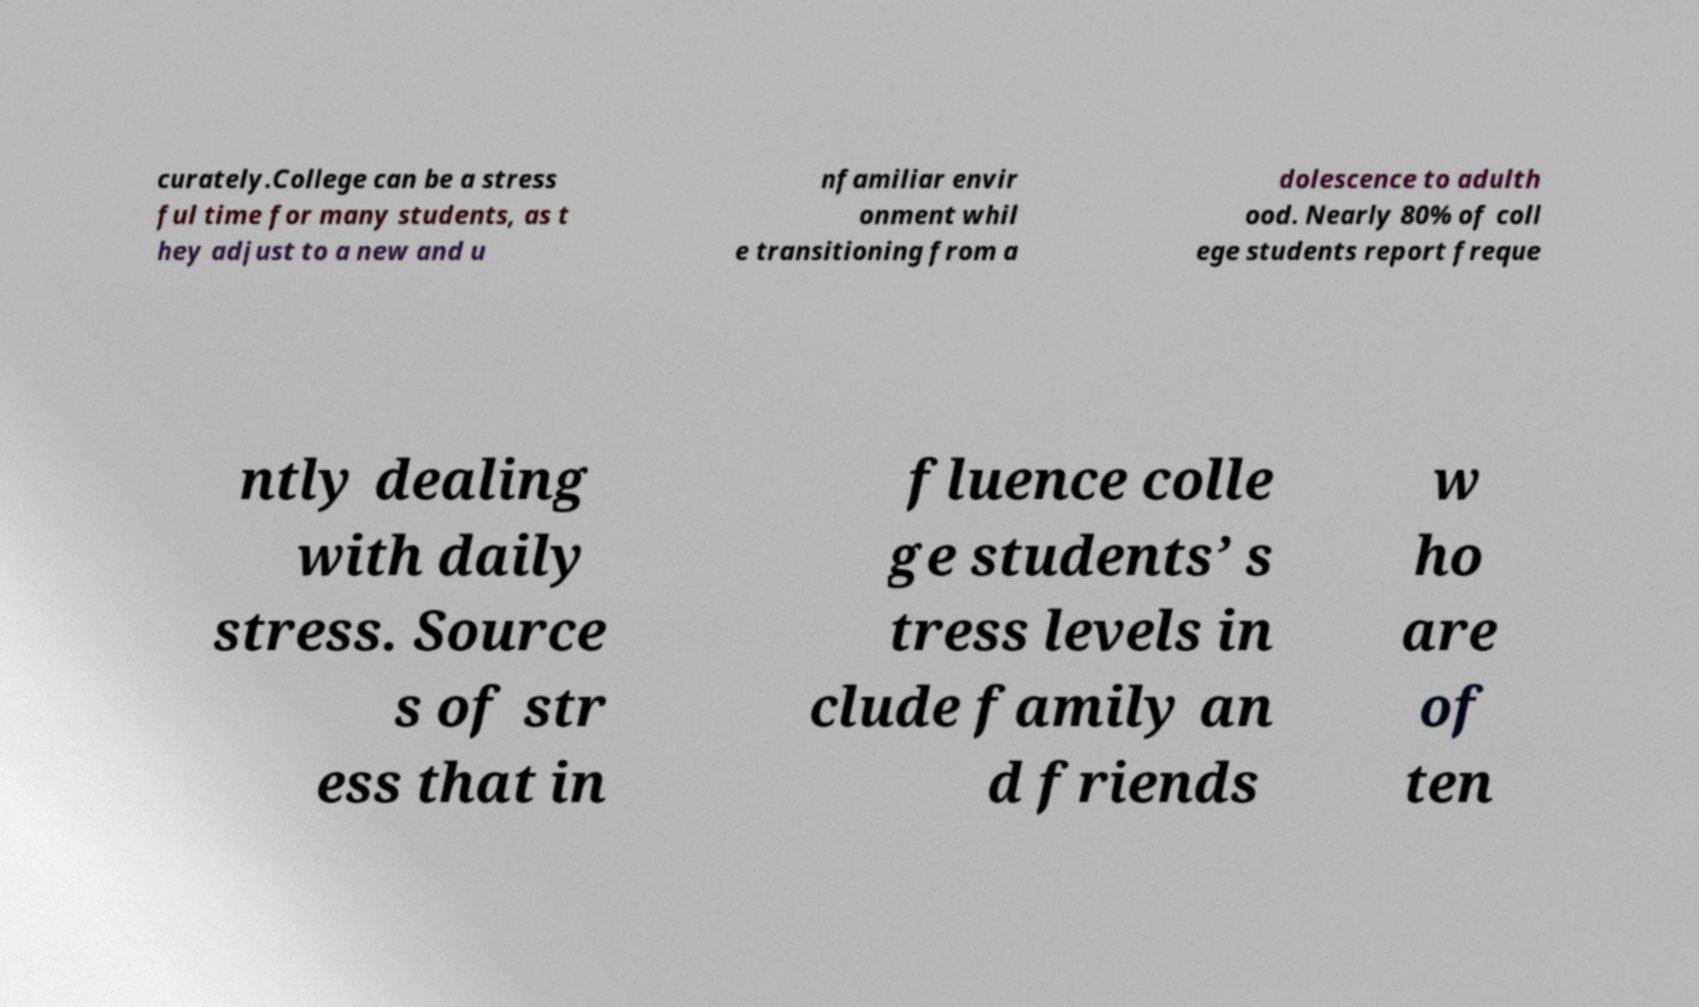Can you read and provide the text displayed in the image?This photo seems to have some interesting text. Can you extract and type it out for me? curately.College can be a stress ful time for many students, as t hey adjust to a new and u nfamiliar envir onment whil e transitioning from a dolescence to adulth ood. Nearly 80% of coll ege students report freque ntly dealing with daily stress. Source s of str ess that in fluence colle ge students’ s tress levels in clude family an d friends w ho are of ten 